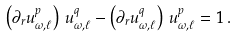<formula> <loc_0><loc_0><loc_500><loc_500>\left ( \partial _ { r } u _ { \omega , \ell } ^ { p } \right ) \, u _ { \omega , \ell } ^ { q } - \left ( \partial _ { r } u _ { \omega , \ell } ^ { q } \right ) \, u _ { \omega , \ell } ^ { p } = 1 \, .</formula> 